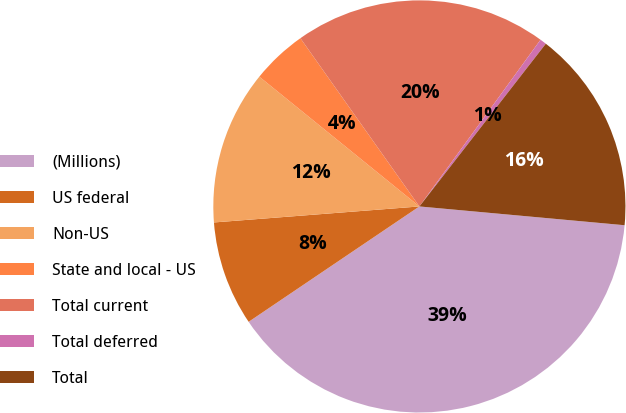<chart> <loc_0><loc_0><loc_500><loc_500><pie_chart><fcel>(Millions)<fcel>US federal<fcel>Non-US<fcel>State and local - US<fcel>Total current<fcel>Total deferred<fcel>Total<nl><fcel>39.09%<fcel>8.22%<fcel>12.08%<fcel>4.36%<fcel>19.8%<fcel>0.51%<fcel>15.94%<nl></chart> 